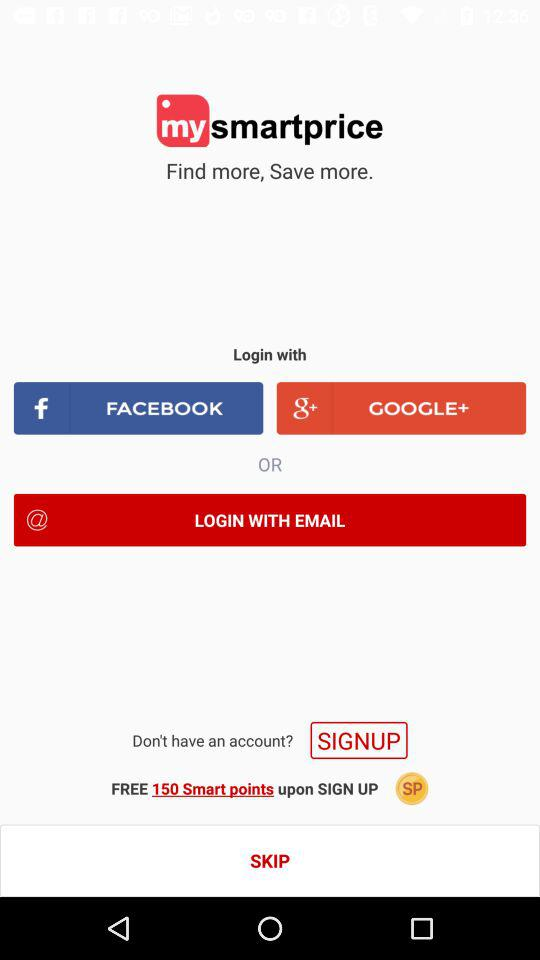How many Smart points will I get for signing up? You will get 150 Smart points for signing up. 